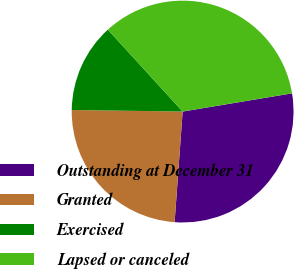<chart> <loc_0><loc_0><loc_500><loc_500><pie_chart><fcel>Outstanding at December 31<fcel>Granted<fcel>Exercised<fcel>Lapsed or canceled<nl><fcel>28.78%<fcel>24.07%<fcel>13.0%<fcel>34.15%<nl></chart> 